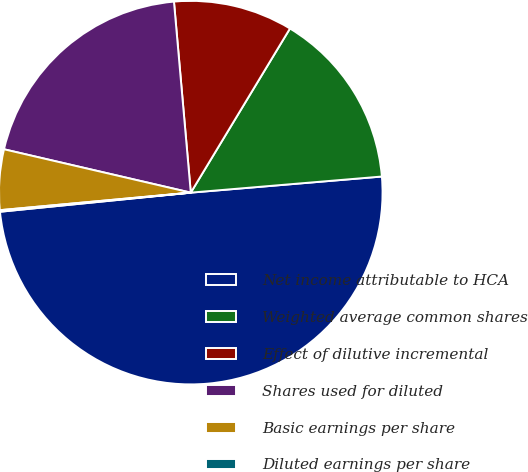<chart> <loc_0><loc_0><loc_500><loc_500><pie_chart><fcel>Net income attributable to HCA<fcel>Weighted average common shares<fcel>Effect of dilutive incremental<fcel>Shares used for diluted<fcel>Basic earnings per share<fcel>Diluted earnings per share<nl><fcel>49.75%<fcel>15.01%<fcel>10.05%<fcel>19.97%<fcel>5.09%<fcel>0.13%<nl></chart> 